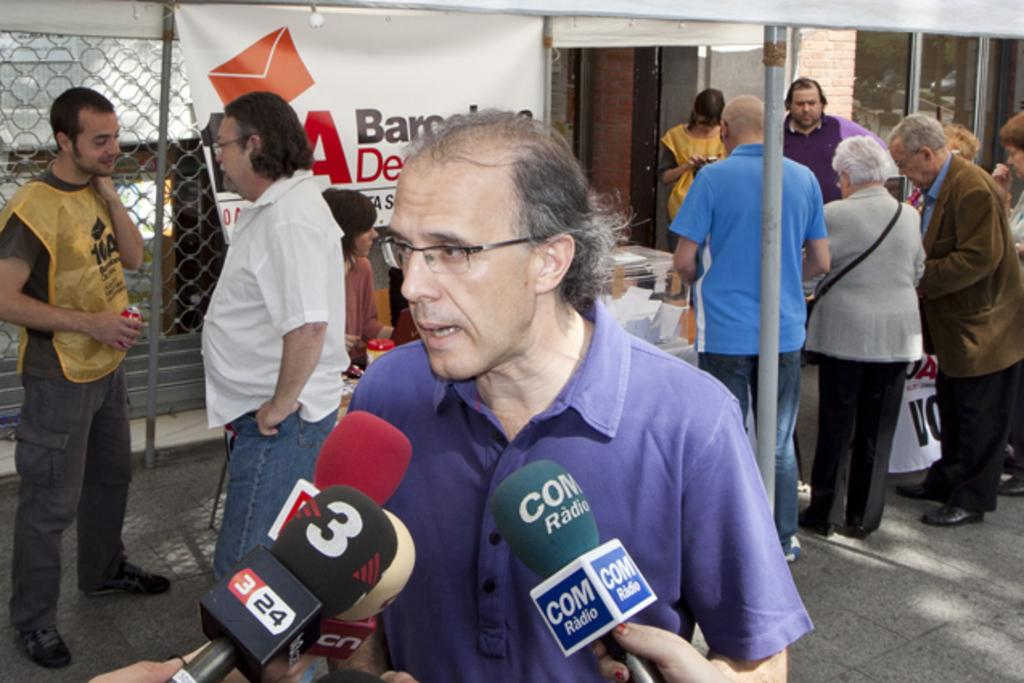Who or what can be seen in the image? There are people in the image. What objects are present that might be used for amplifying sound? There are microphones in the image. What type of temporary shelter is visible in the image? There is a tent in the image. What decorative or informative items can be seen in the image? There are banners in the image. What structural elements are present in the image? There are poles in the image. What general term can be used to describe the various items in the image? There are objects in the image. What can be seen in the background of the image that might provide a barrier or visual separation? There is a mesh, a wall, and glass in the background of the image. How does the fold of the tent affect the sound quality in the image? The fold of the tent does not affect the sound quality in the image, as it is not mentioned to have any impact on the microphones or people speaking. What type of throat condition can be seen in the image? There is no mention of any throat conditions or people experiencing discomfort in the image. 